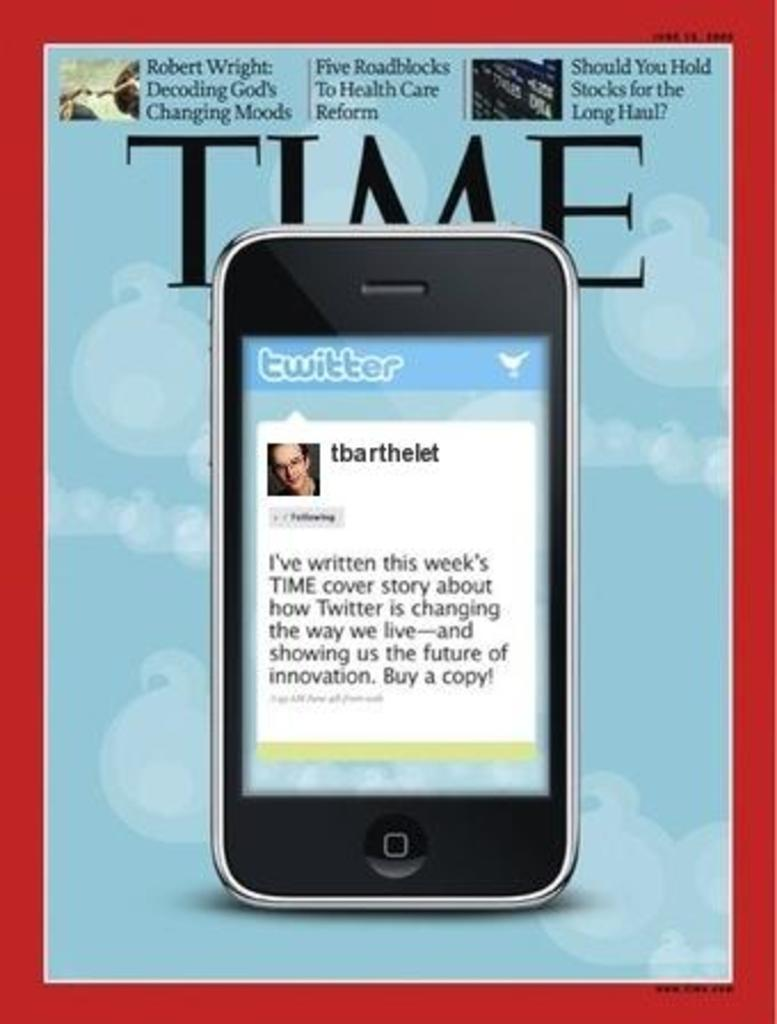<image>
Render a clear and concise summary of the photo. The cover of time magazine that features a cell phone screen displaying a tweet. 